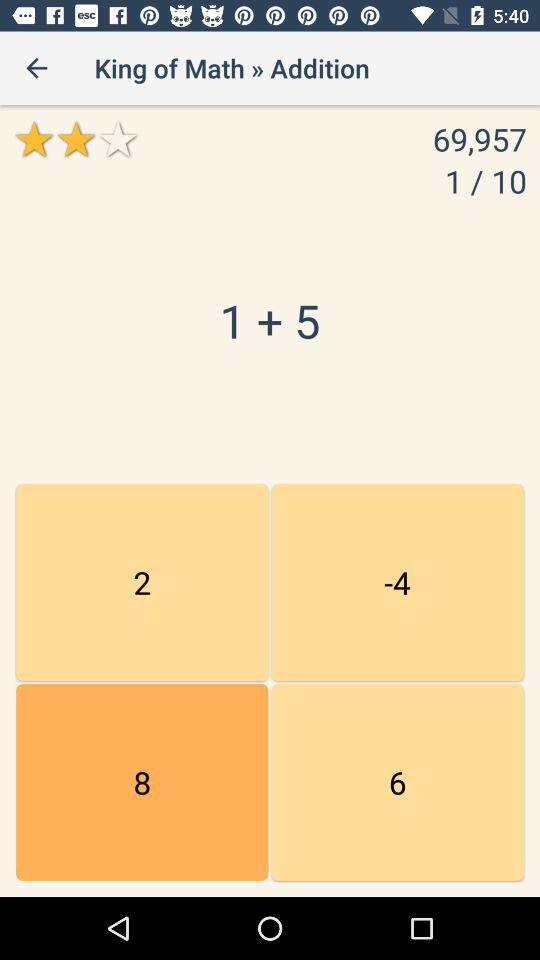What is the given rating? The given rating is 2 stars. 